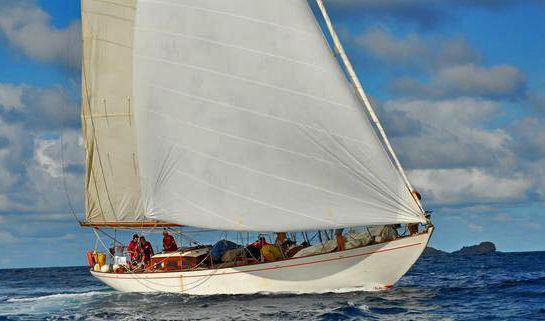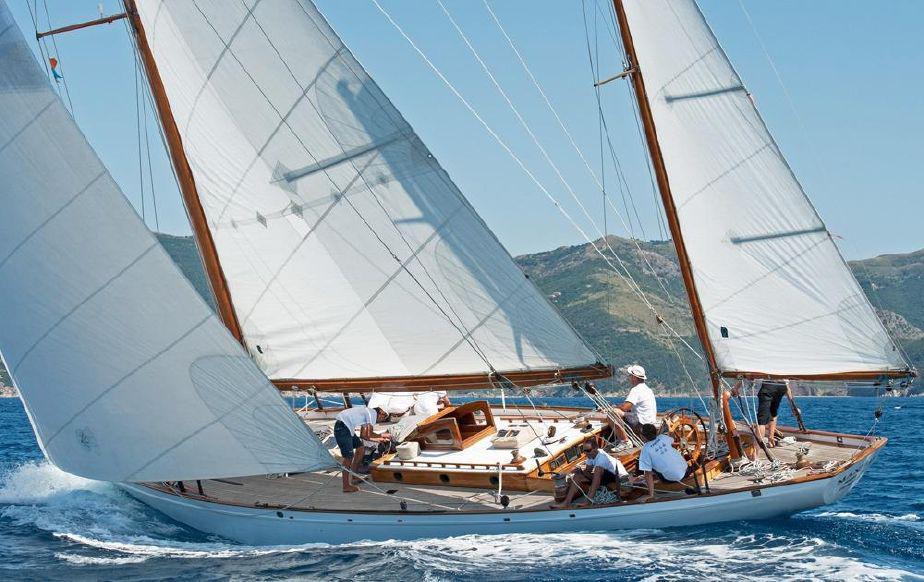The first image is the image on the left, the second image is the image on the right. Considering the images on both sides, is "All boats are tilted." valid? Answer yes or no. No. 